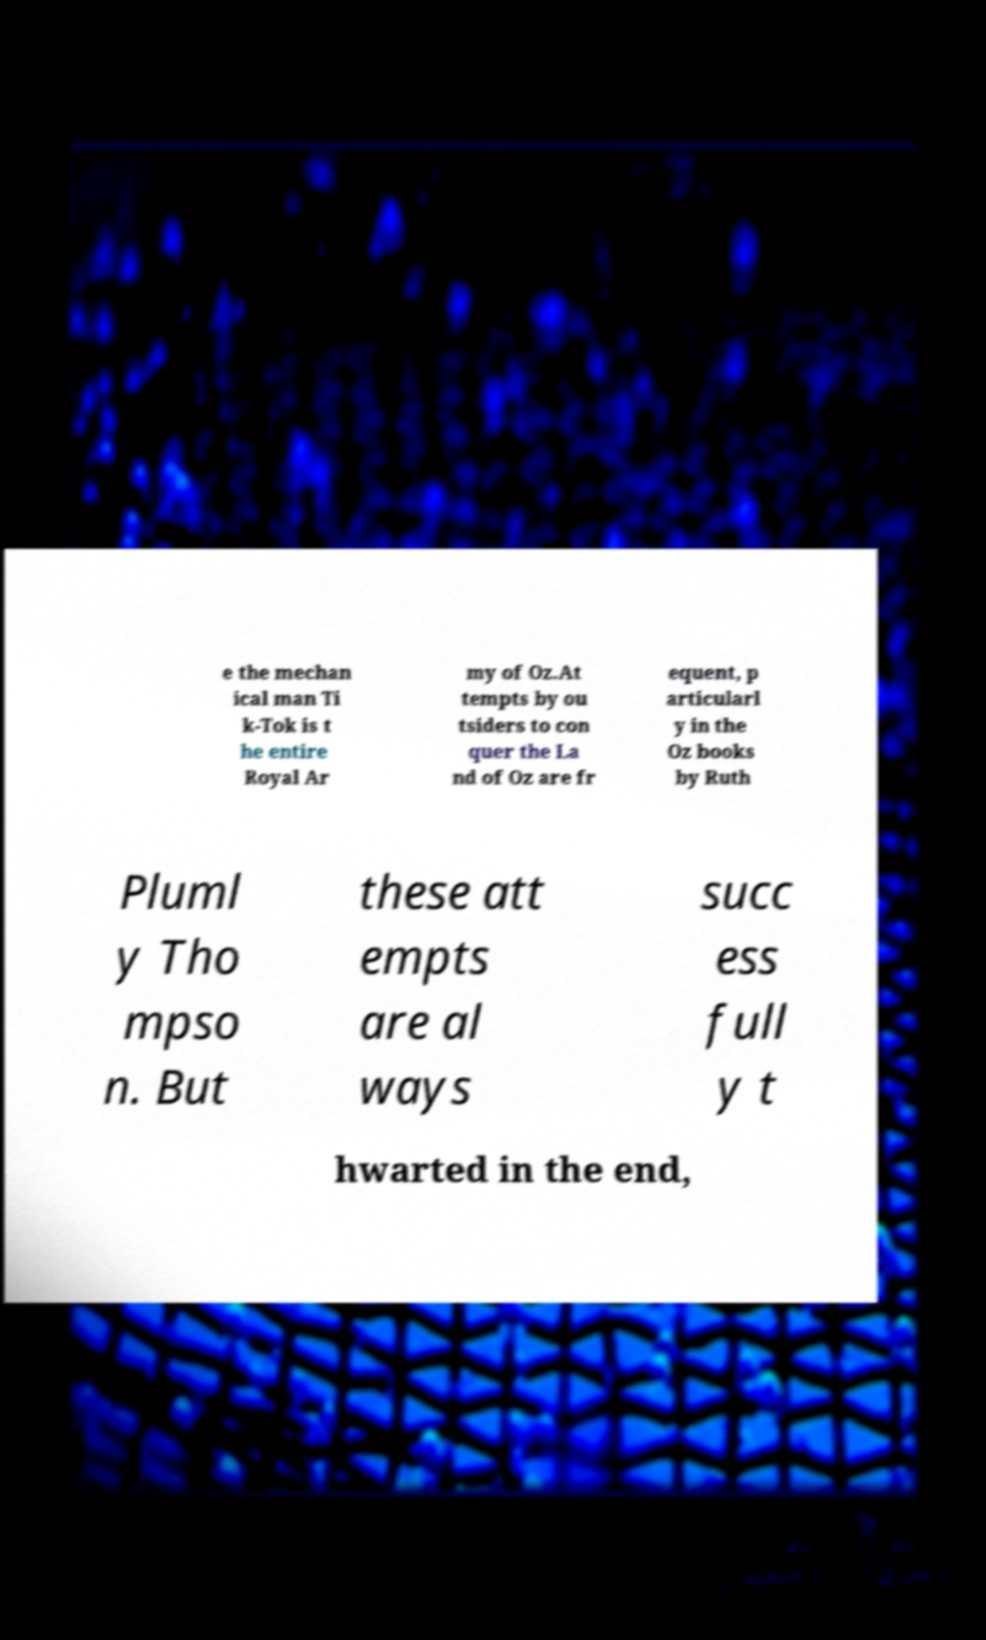I need the written content from this picture converted into text. Can you do that? e the mechan ical man Ti k-Tok is t he entire Royal Ar my of Oz.At tempts by ou tsiders to con quer the La nd of Oz are fr equent, p articularl y in the Oz books by Ruth Pluml y Tho mpso n. But these att empts are al ways succ ess full y t hwarted in the end, 